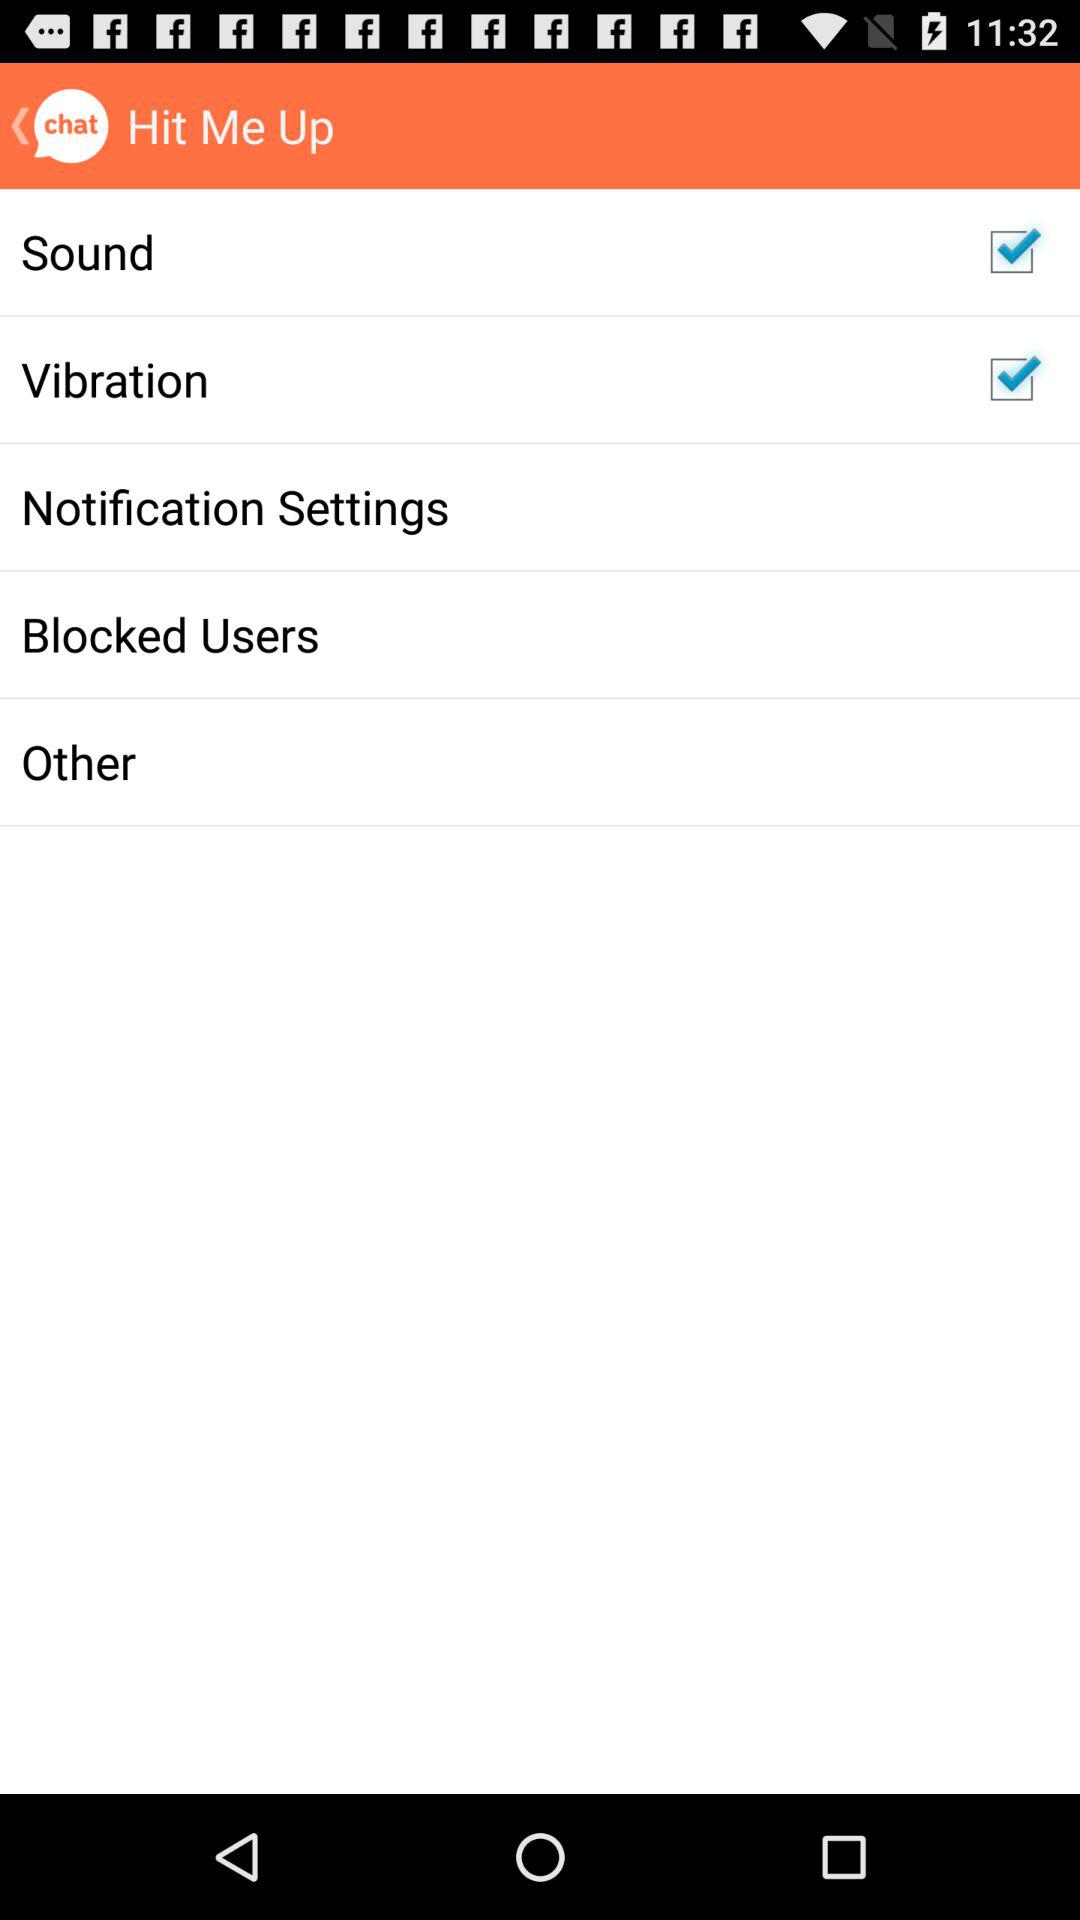What is the status of "Blocked Users"?
When the provided information is insufficient, respond with <no answer>. <no answer> 